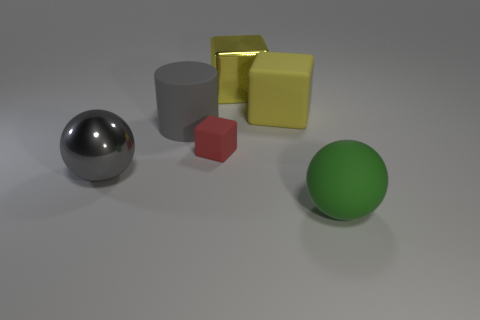Subtract all purple balls. How many yellow blocks are left? 2 Subtract all matte blocks. How many blocks are left? 1 Add 3 red matte cubes. How many objects exist? 9 Subtract all cylinders. How many objects are left? 5 Add 6 small gray rubber cylinders. How many small gray rubber cylinders exist? 6 Subtract 1 green spheres. How many objects are left? 5 Subtract all shiny spheres. Subtract all large gray spheres. How many objects are left? 4 Add 3 big gray cylinders. How many big gray cylinders are left? 4 